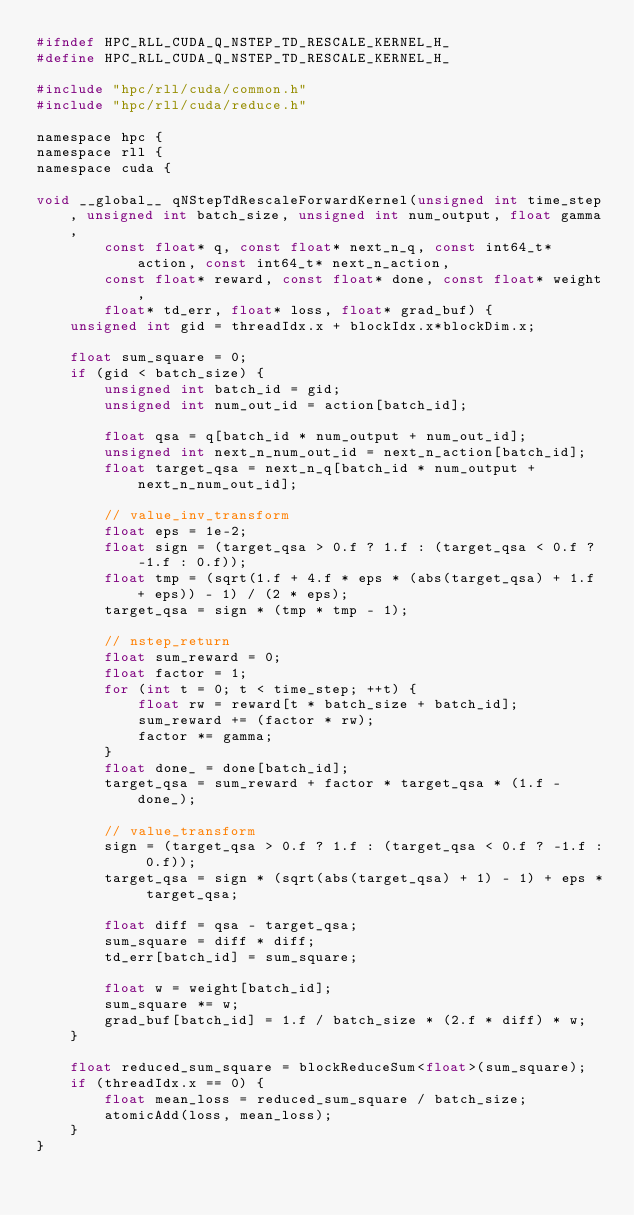<code> <loc_0><loc_0><loc_500><loc_500><_C_>#ifndef HPC_RLL_CUDA_Q_NSTEP_TD_RESCALE_KERNEL_H_
#define HPC_RLL_CUDA_Q_NSTEP_TD_RESCALE_KERNEL_H_

#include "hpc/rll/cuda/common.h"
#include "hpc/rll/cuda/reduce.h"

namespace hpc {
namespace rll {
namespace cuda {

void __global__ qNStepTdRescaleForwardKernel(unsigned int time_step, unsigned int batch_size, unsigned int num_output, float gamma,
        const float* q, const float* next_n_q, const int64_t* action, const int64_t* next_n_action,
        const float* reward, const float* done, const float* weight,
        float* td_err, float* loss, float* grad_buf) {
    unsigned int gid = threadIdx.x + blockIdx.x*blockDim.x;

    float sum_square = 0;
    if (gid < batch_size) {
        unsigned int batch_id = gid;
        unsigned int num_out_id = action[batch_id];

        float qsa = q[batch_id * num_output + num_out_id];
        unsigned int next_n_num_out_id = next_n_action[batch_id];
        float target_qsa = next_n_q[batch_id * num_output + next_n_num_out_id];

        // value_inv_transform
        float eps = 1e-2;
        float sign = (target_qsa > 0.f ? 1.f : (target_qsa < 0.f ? -1.f : 0.f));
        float tmp = (sqrt(1.f + 4.f * eps * (abs(target_qsa) + 1.f + eps)) - 1) / (2 * eps);
        target_qsa = sign * (tmp * tmp - 1);

        // nstep_return
        float sum_reward = 0;
        float factor = 1;
        for (int t = 0; t < time_step; ++t) {
            float rw = reward[t * batch_size + batch_id];
            sum_reward += (factor * rw);
            factor *= gamma;
        }
        float done_ = done[batch_id];
        target_qsa = sum_reward + factor * target_qsa * (1.f - done_);

        // value_transform
        sign = (target_qsa > 0.f ? 1.f : (target_qsa < 0.f ? -1.f : 0.f));
        target_qsa = sign * (sqrt(abs(target_qsa) + 1) - 1) + eps * target_qsa;

        float diff = qsa - target_qsa;
        sum_square = diff * diff;
        td_err[batch_id] = sum_square;

        float w = weight[batch_id];
        sum_square *= w;
        grad_buf[batch_id] = 1.f / batch_size * (2.f * diff) * w;
    }

    float reduced_sum_square = blockReduceSum<float>(sum_square);
    if (threadIdx.x == 0) {
        float mean_loss = reduced_sum_square / batch_size;
        atomicAdd(loss, mean_loss);
    }
}
</code> 